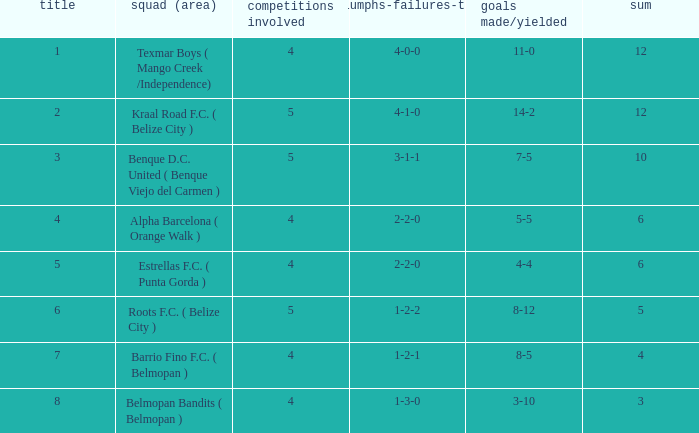What is the minimum games played with goals for/against being 7-5 5.0. 